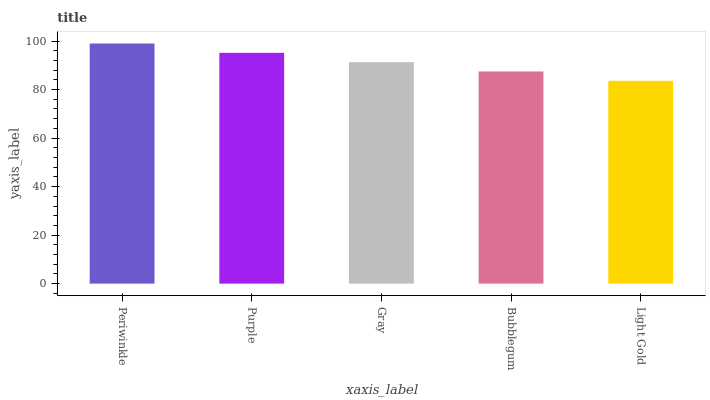Is Light Gold the minimum?
Answer yes or no. Yes. Is Periwinkle the maximum?
Answer yes or no. Yes. Is Purple the minimum?
Answer yes or no. No. Is Purple the maximum?
Answer yes or no. No. Is Periwinkle greater than Purple?
Answer yes or no. Yes. Is Purple less than Periwinkle?
Answer yes or no. Yes. Is Purple greater than Periwinkle?
Answer yes or no. No. Is Periwinkle less than Purple?
Answer yes or no. No. Is Gray the high median?
Answer yes or no. Yes. Is Gray the low median?
Answer yes or no. Yes. Is Periwinkle the high median?
Answer yes or no. No. Is Bubblegum the low median?
Answer yes or no. No. 